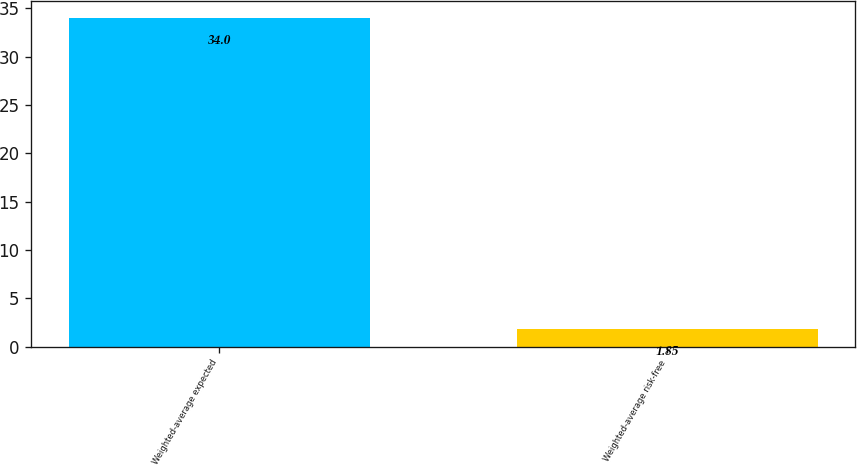<chart> <loc_0><loc_0><loc_500><loc_500><bar_chart><fcel>Weighted-average expected<fcel>Weighted-average risk-free<nl><fcel>34<fcel>1.85<nl></chart> 